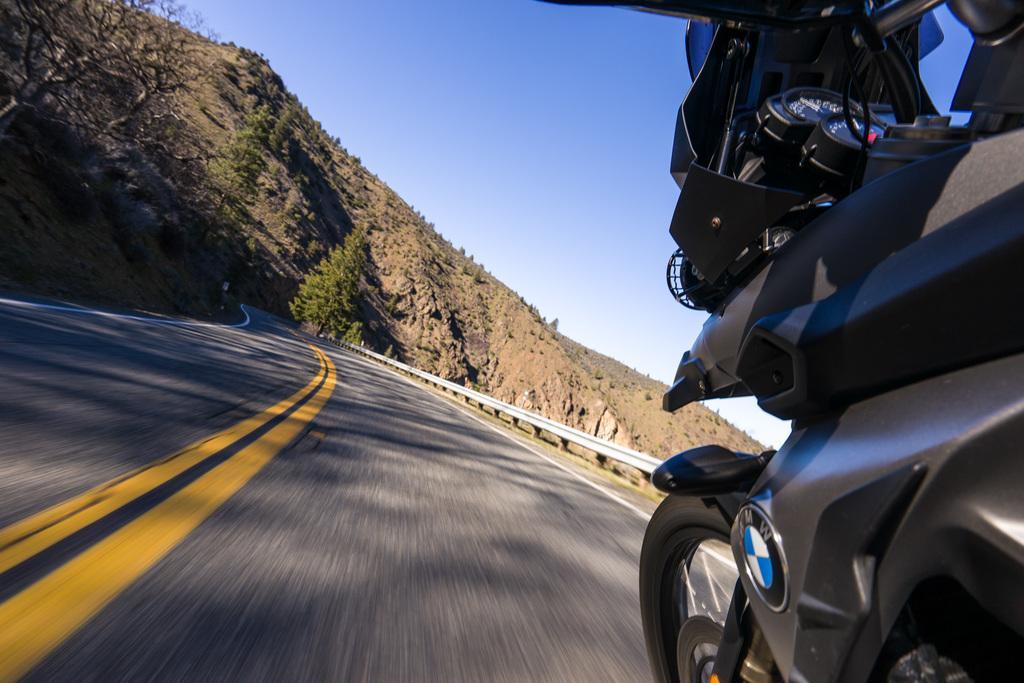Could you give a brief overview of what you see in this image? In this image, we can see a bike, we can see the road, there are some trees, we can see the mountain, at the top there is a blue sky. 